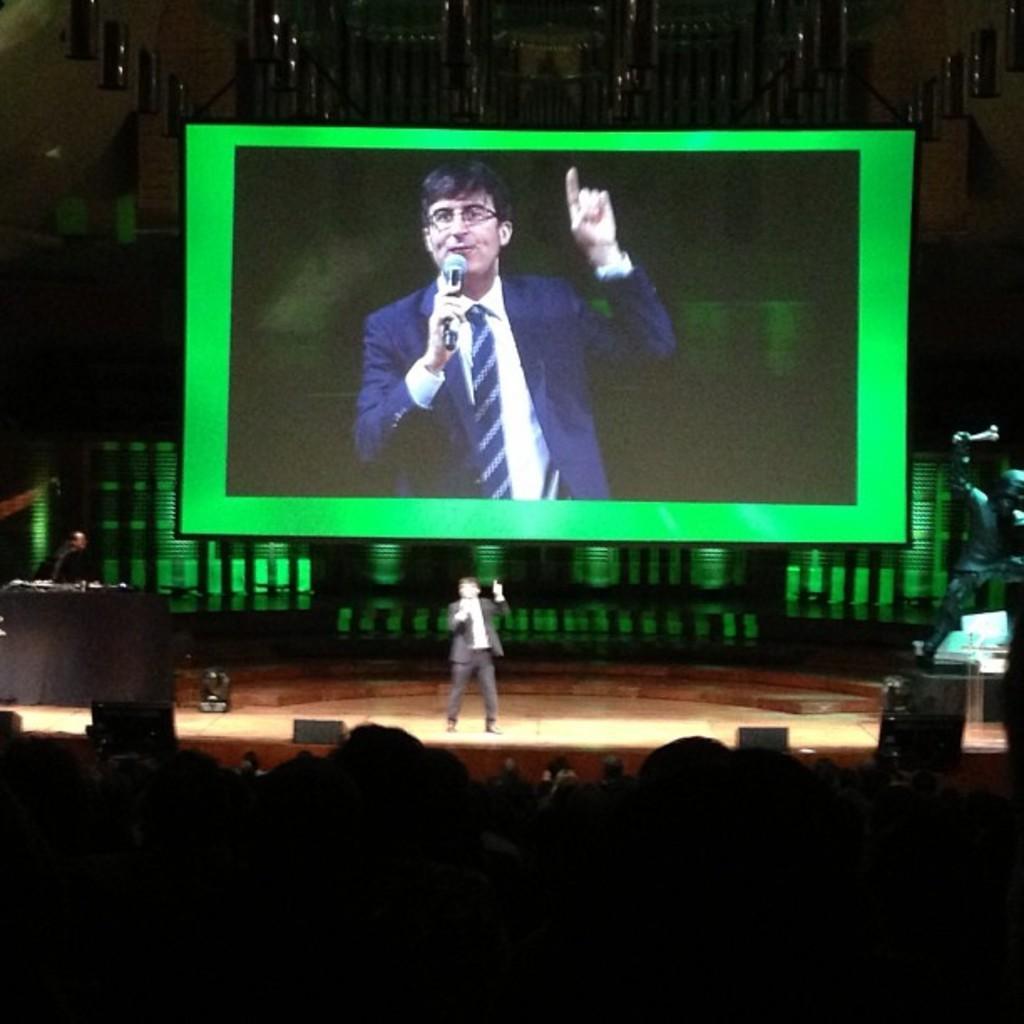How would you summarize this image in a sentence or two? In the foreground it is dark. In the center of the picture there is a stage, on the stage there is a person standing holding a mic and talking. On the right there is a desk, desktop and some other objects. On the left we can see a desk and a person. At the top there is a screen, in the screen we can see a person. At the top it is dark. In the foreground it is looking like there are heads of people. 